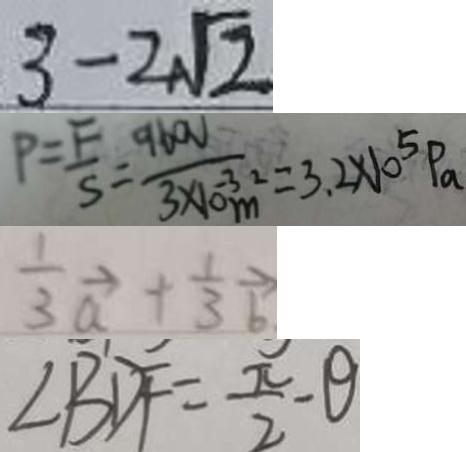Convert formula to latex. <formula><loc_0><loc_0><loc_500><loc_500>3 - 2 \sqrt { 2 } 
 P = \frac { F } { S } = \frac { 9 6 0 V } { 3 \times 1 0 ^ { - 3 } m ^ { 2 } } = 3 . 2 \times 1 0 ^ { 5 } P _ { a } 
 \frac { 1 } { 3 } \overrightarrow { a } + \frac { 1 } { 3 } \overrightarrow { b } 
 \angle B D F = \frac { \pi } { 2 } - \theta</formula> 